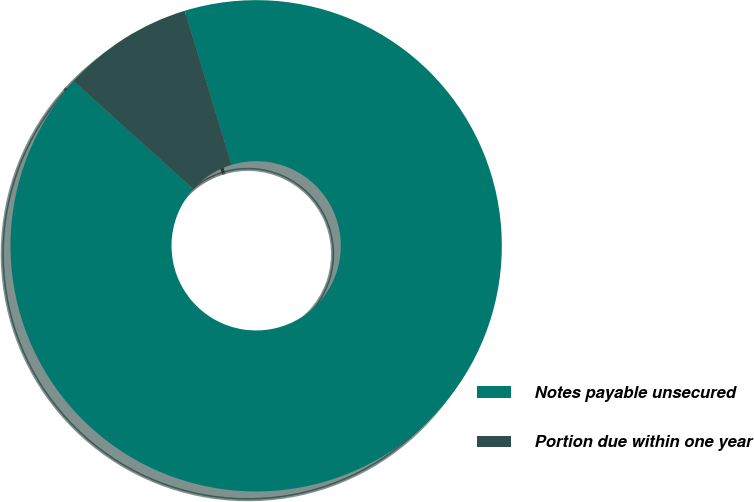Convert chart to OTSL. <chart><loc_0><loc_0><loc_500><loc_500><pie_chart><fcel>Notes payable unsecured<fcel>Portion due within one year<nl><fcel>91.38%<fcel>8.62%<nl></chart> 